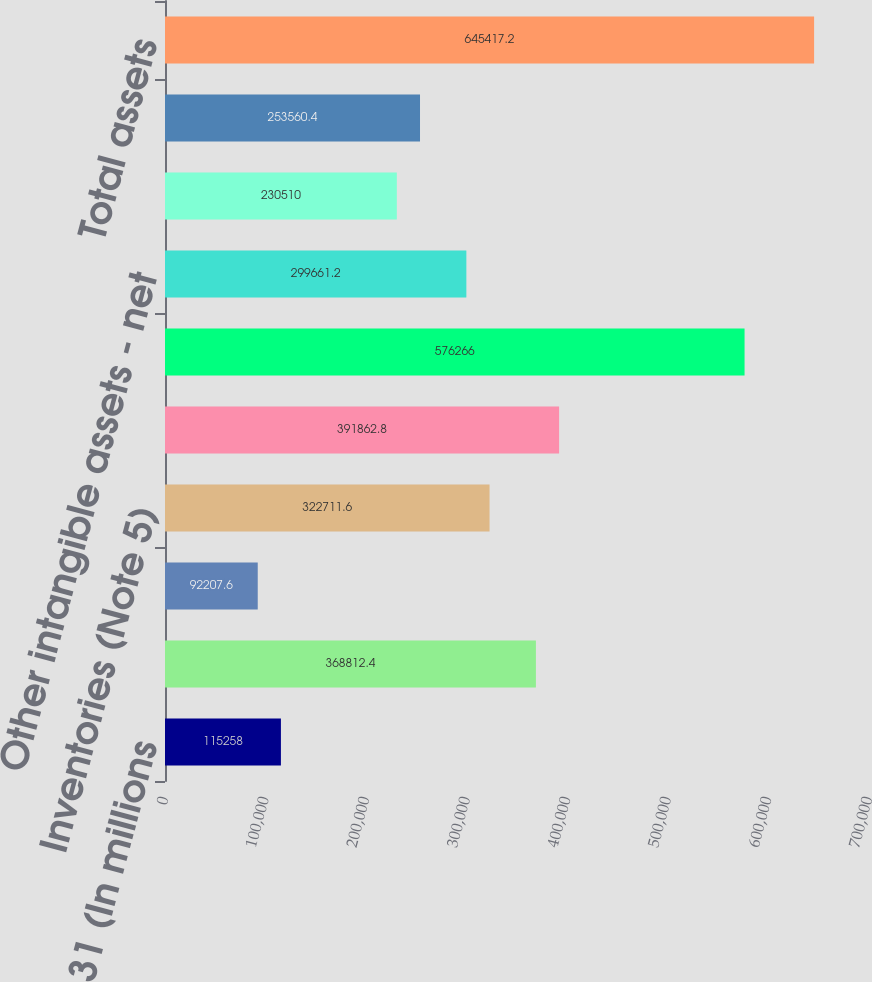Convert chart to OTSL. <chart><loc_0><loc_0><loc_500><loc_500><bar_chart><fcel>December 31 (In millions<fcel>Cash cash equivalents and<fcel>Investment securities (Note 3)<fcel>Inventories (Note 5)<fcel>Property plant and equipment -<fcel>Goodwill (Note 8)<fcel>Other intangible assets - net<fcel>All other assets<fcel>Deferred income taxes (Note<fcel>Total assets<nl><fcel>115258<fcel>368812<fcel>92207.6<fcel>322712<fcel>391863<fcel>576266<fcel>299661<fcel>230510<fcel>253560<fcel>645417<nl></chart> 